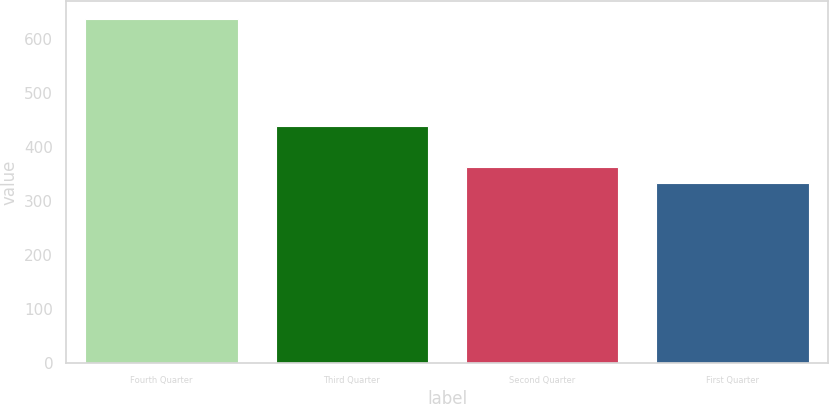Convert chart to OTSL. <chart><loc_0><loc_0><loc_500><loc_500><bar_chart><fcel>Fourth Quarter<fcel>Third Quarter<fcel>Second Quarter<fcel>First Quarter<nl><fcel>638<fcel>439.6<fcel>363.14<fcel>332.6<nl></chart> 